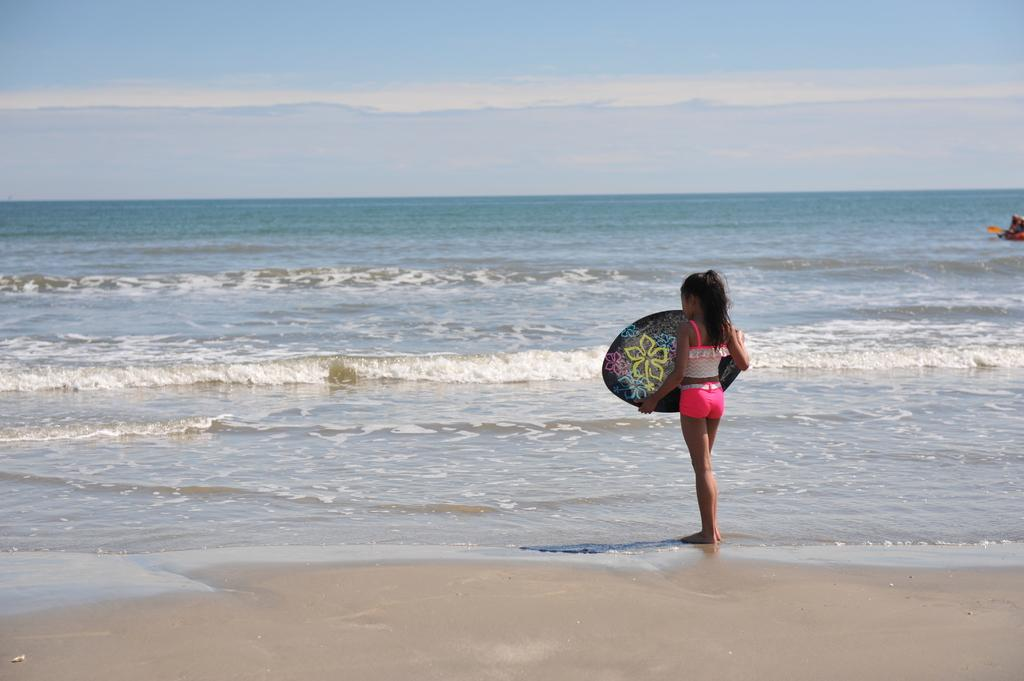Where is the setting of the image? The image is set outside of a city. What is the woman in the image doing? The woman is standing in the image and holding a skateboard. What is the woman wearing? The woman is wearing a beautiful dress. What can be seen in the background of the image? There is a sea and the sky visible in the background of the image. What type of destruction can be seen in the image? There is no destruction present in the image; it features a woman standing outside with a skateboard and a beautiful dress, with a sea and sky visible in the background. 